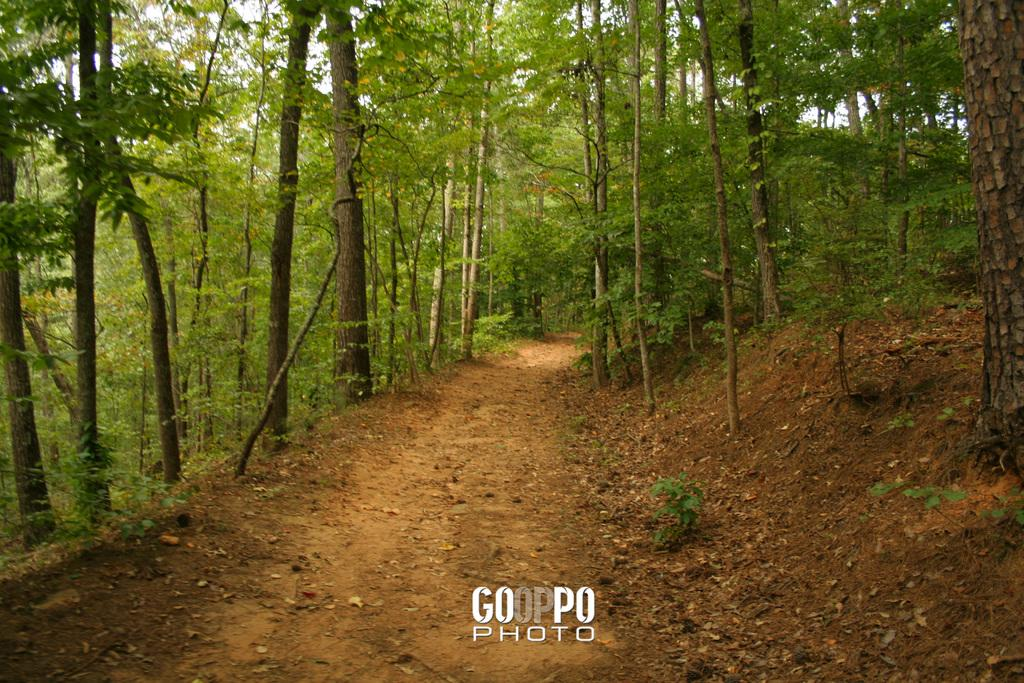What is the main feature at the center of the image? There is a path at the center of the image. What can be seen on the left side of the image? There are trees on the left side of the image. What is present on the right side of the image? There are trees on the right side of the image. What type of toys can be seen being carried by the porter in the image? There is no porter or toys present in the image. Is there any writing visible on the trees in the image? There is no writing visible on the trees in the image. 